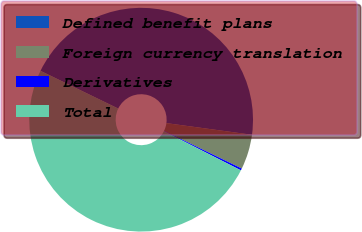Convert chart. <chart><loc_0><loc_0><loc_500><loc_500><pie_chart><fcel>Defined benefit plans<fcel>Foreign currency translation<fcel>Derivatives<fcel>Total<nl><fcel>44.96%<fcel>5.04%<fcel>0.29%<fcel>49.71%<nl></chart> 